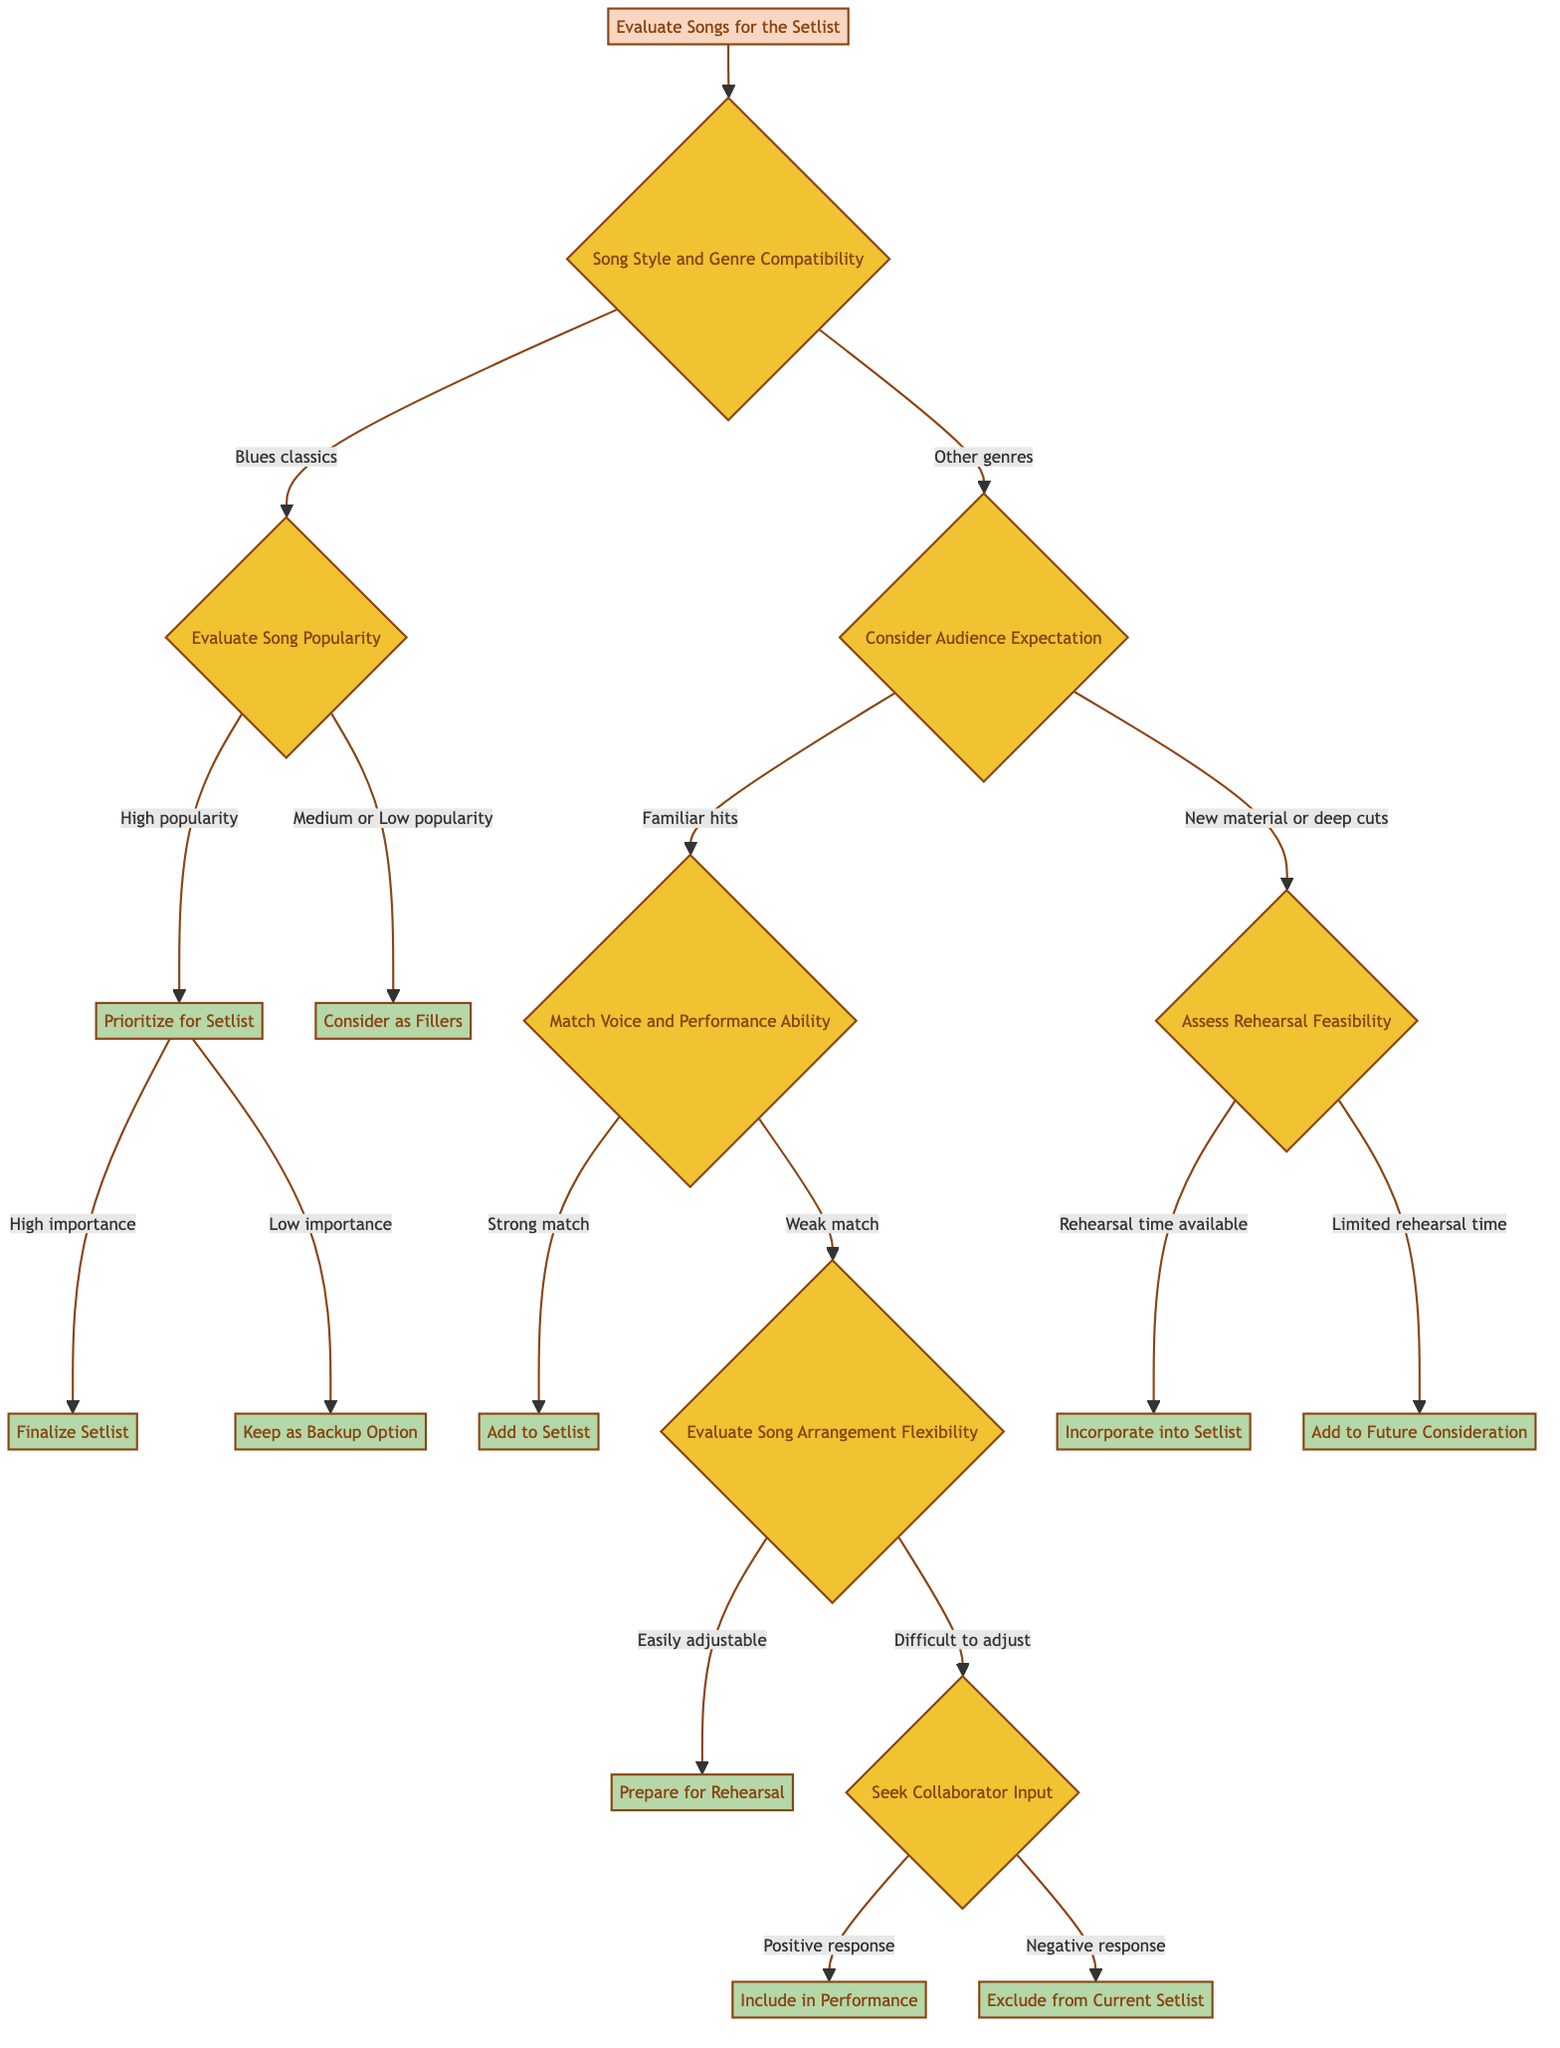What's the first element to evaluate in the decision tree? The decision tree starts with "Evaluate Songs for the Setlist," which is the initial action to be taken.
Answer: Evaluate Songs for the Setlist How many outcomes are there after evaluating the song popularity? After evaluating the song popularity, there are two outcomes: "Prioritize for Setlist" and "Consider as Fillers."
Answer: Two What happens if the song is a familiar hit but there's a weak match with voice and performance ability? If the song is a familiar hit and there's a weak match, the next step is to "Evaluate Song Arrangement Flexibility."
Answer: Evaluate Song Arrangement Flexibility What condition leads to incorporating new material into the setlist? Incorporating new material happens when there is "Rehearsal time available."
Answer: Rehearsal time available What decision follows if the song is categorized under blues classics with high popularity? For blues classics with high popularity, the action is to "Prioritize for Setlist."
Answer: Prioritize for Setlist What is the outcome if there’s a negative response from a collaborator after seeking input? A negative response from a collaborator leads to the action of "Exclude from Current Setlist."
Answer: Exclude from Current Setlist What element comes after considering audience expectation for new material or deep cuts? After considering audience expectations for new material or deep cuts, the next step is to "Assess Rehearsal Feasibility."
Answer: Assess Rehearsal Feasibility What does the decision tree suggest if the song arrangement is easily adjustable? If the song arrangement is easily adjustable, the recommendation is to "Prepare for Rehearsal."
Answer: Prepare for Rehearsal What action is taken if a song prioritized for the setlist has low importance? If the song prioritized for the setlist has low importance, it will be kept as a "Backup Option."
Answer: Keep as Backup Option 